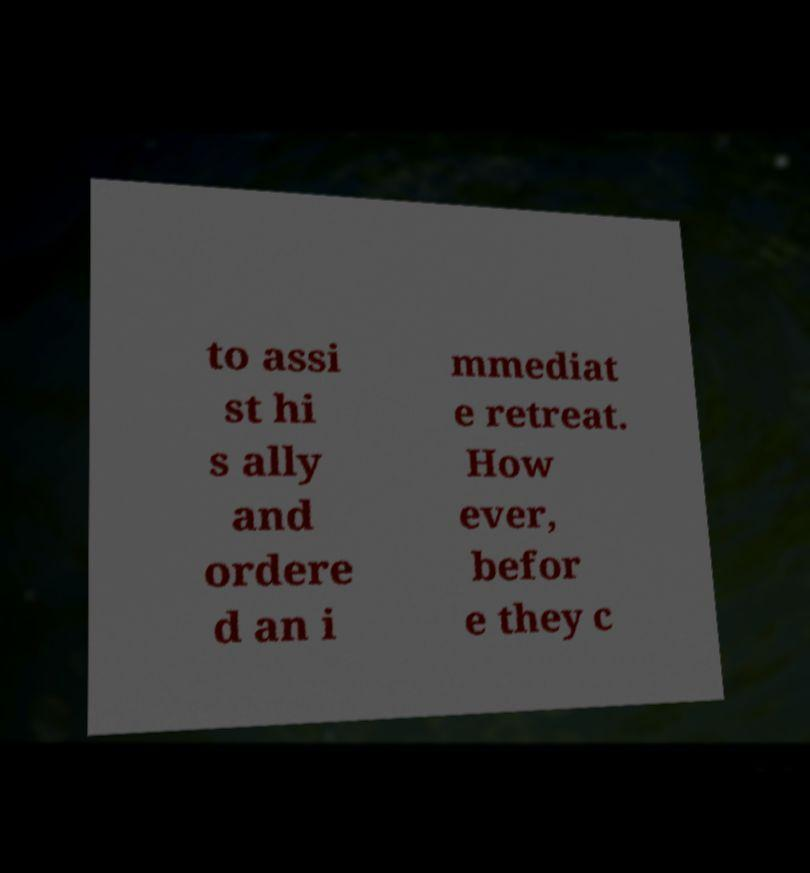Could you assist in decoding the text presented in this image and type it out clearly? to assi st hi s ally and ordere d an i mmediat e retreat. How ever, befor e they c 